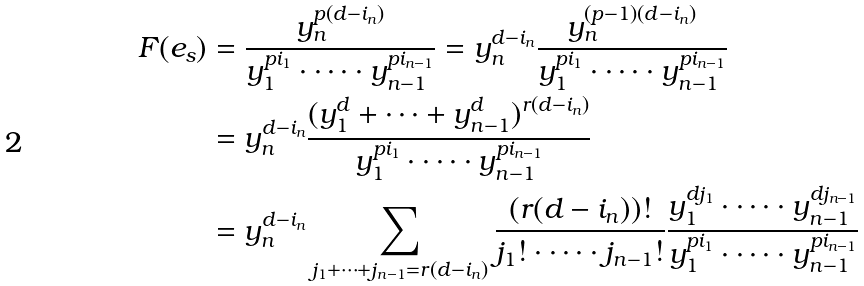Convert formula to latex. <formula><loc_0><loc_0><loc_500><loc_500>F ( e _ { s } ) & = \frac { y _ { n } ^ { p ( d - i _ { n } ) } } { y _ { 1 } ^ { p i _ { 1 } } \cdot \dots \cdot y _ { n - 1 } ^ { p i _ { n - 1 } } } = y _ { n } ^ { d - i _ { n } } \frac { y _ { n } ^ { ( p - 1 ) ( d - i _ { n } ) } } { y _ { 1 } ^ { p i _ { 1 } } \cdot \dots \cdot y _ { n - 1 } ^ { p i _ { n - 1 } } } \\ & = y _ { n } ^ { d - i _ { n } } \frac { ( y _ { 1 } ^ { d } + \dots + y _ { n - 1 } ^ { d } ) ^ { r ( d - i _ { n } ) } } { y _ { 1 } ^ { p i _ { 1 } } \cdot \dots \cdot y _ { n - 1 } ^ { p i _ { n - 1 } } } \\ & = y _ { n } ^ { d - i _ { n } } \sum _ { j _ { 1 } + \cdots + j _ { n - 1 } = r ( d - i _ { n } ) } \frac { ( r ( d - i _ { n } ) ) ! } { j _ { 1 } ! \cdot \dots \cdot j _ { n - 1 } ! } \frac { y _ { 1 } ^ { d j _ { 1 } } \cdot \dots \cdot y _ { n - 1 } ^ { d j _ { n - 1 } } } { y _ { 1 } ^ { p i _ { 1 } } \cdot \dots \cdot y _ { n - 1 } ^ { p i _ { n - 1 } } }</formula> 